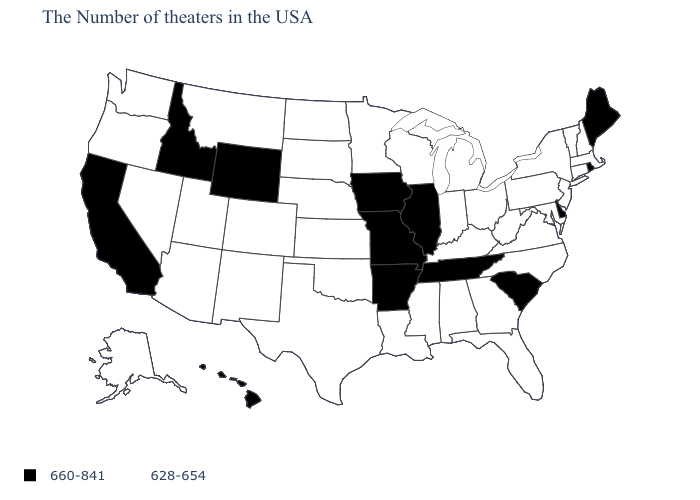Among the states that border Maine , which have the lowest value?
Answer briefly. New Hampshire. Which states have the lowest value in the South?
Concise answer only. Maryland, Virginia, North Carolina, West Virginia, Florida, Georgia, Kentucky, Alabama, Mississippi, Louisiana, Oklahoma, Texas. What is the lowest value in the USA?
Keep it brief. 628-654. Is the legend a continuous bar?
Answer briefly. No. Does Rhode Island have a lower value than New York?
Quick response, please. No. Name the states that have a value in the range 660-841?
Write a very short answer. Maine, Rhode Island, Delaware, South Carolina, Tennessee, Illinois, Missouri, Arkansas, Iowa, Wyoming, Idaho, California, Hawaii. Which states have the lowest value in the USA?
Short answer required. Massachusetts, New Hampshire, Vermont, Connecticut, New York, New Jersey, Maryland, Pennsylvania, Virginia, North Carolina, West Virginia, Ohio, Florida, Georgia, Michigan, Kentucky, Indiana, Alabama, Wisconsin, Mississippi, Louisiana, Minnesota, Kansas, Nebraska, Oklahoma, Texas, South Dakota, North Dakota, Colorado, New Mexico, Utah, Montana, Arizona, Nevada, Washington, Oregon, Alaska. Name the states that have a value in the range 628-654?
Give a very brief answer. Massachusetts, New Hampshire, Vermont, Connecticut, New York, New Jersey, Maryland, Pennsylvania, Virginia, North Carolina, West Virginia, Ohio, Florida, Georgia, Michigan, Kentucky, Indiana, Alabama, Wisconsin, Mississippi, Louisiana, Minnesota, Kansas, Nebraska, Oklahoma, Texas, South Dakota, North Dakota, Colorado, New Mexico, Utah, Montana, Arizona, Nevada, Washington, Oregon, Alaska. Name the states that have a value in the range 660-841?
Concise answer only. Maine, Rhode Island, Delaware, South Carolina, Tennessee, Illinois, Missouri, Arkansas, Iowa, Wyoming, Idaho, California, Hawaii. What is the value of Delaware?
Be succinct. 660-841. Does the map have missing data?
Keep it brief. No. What is the highest value in the USA?
Quick response, please. 660-841. What is the value of California?
Answer briefly. 660-841. What is the highest value in the Northeast ?
Quick response, please. 660-841. What is the value of North Carolina?
Answer briefly. 628-654. 